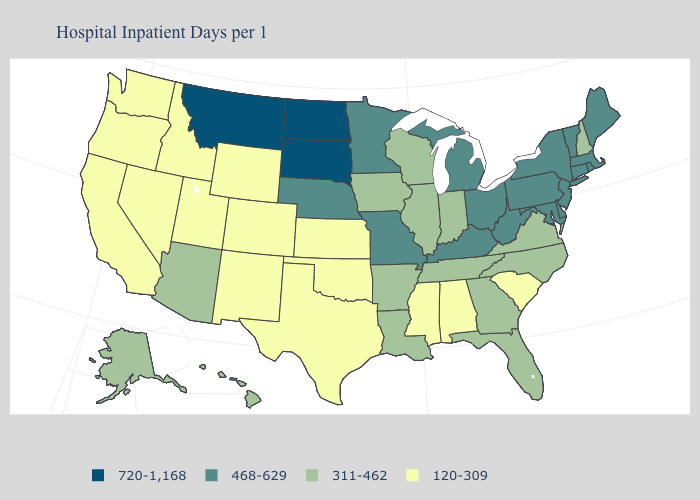Name the states that have a value in the range 120-309?
Be succinct. Alabama, California, Colorado, Idaho, Kansas, Mississippi, Nevada, New Mexico, Oklahoma, Oregon, South Carolina, Texas, Utah, Washington, Wyoming. What is the highest value in the West ?
Keep it brief. 720-1,168. Does Mississippi have the lowest value in the USA?
Write a very short answer. Yes. Which states hav the highest value in the West?
Write a very short answer. Montana. Name the states that have a value in the range 120-309?
Keep it brief. Alabama, California, Colorado, Idaho, Kansas, Mississippi, Nevada, New Mexico, Oklahoma, Oregon, South Carolina, Texas, Utah, Washington, Wyoming. What is the highest value in the USA?
Quick response, please. 720-1,168. Among the states that border Massachusetts , does Rhode Island have the lowest value?
Short answer required. No. What is the value of Massachusetts?
Short answer required. 468-629. What is the value of Florida?
Be succinct. 311-462. Does Delaware have the highest value in the South?
Be succinct. Yes. Does California have a higher value than Kentucky?
Give a very brief answer. No. What is the highest value in the USA?
Give a very brief answer. 720-1,168. Does Pennsylvania have the highest value in the USA?
Write a very short answer. No. Name the states that have a value in the range 120-309?
Short answer required. Alabama, California, Colorado, Idaho, Kansas, Mississippi, Nevada, New Mexico, Oklahoma, Oregon, South Carolina, Texas, Utah, Washington, Wyoming. Does North Dakota have the same value as Iowa?
Quick response, please. No. 